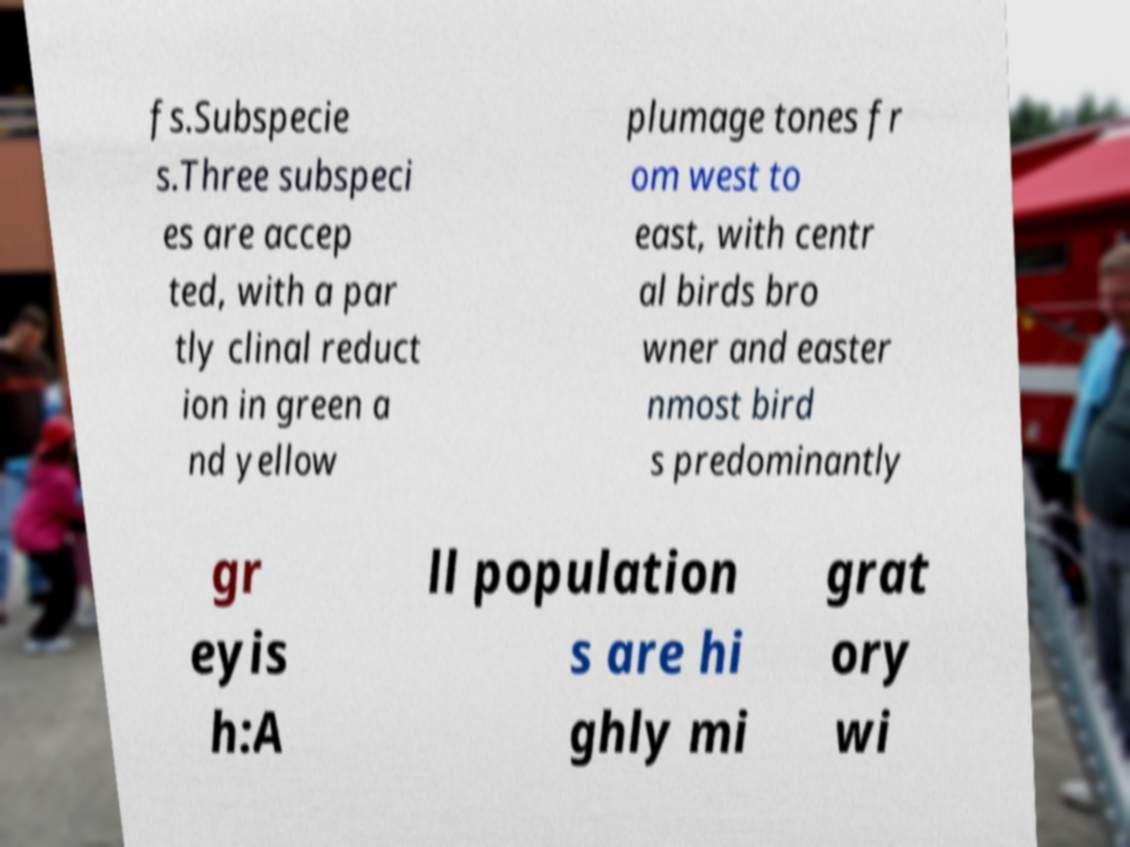I need the written content from this picture converted into text. Can you do that? fs.Subspecie s.Three subspeci es are accep ted, with a par tly clinal reduct ion in green a nd yellow plumage tones fr om west to east, with centr al birds bro wner and easter nmost bird s predominantly gr eyis h:A ll population s are hi ghly mi grat ory wi 